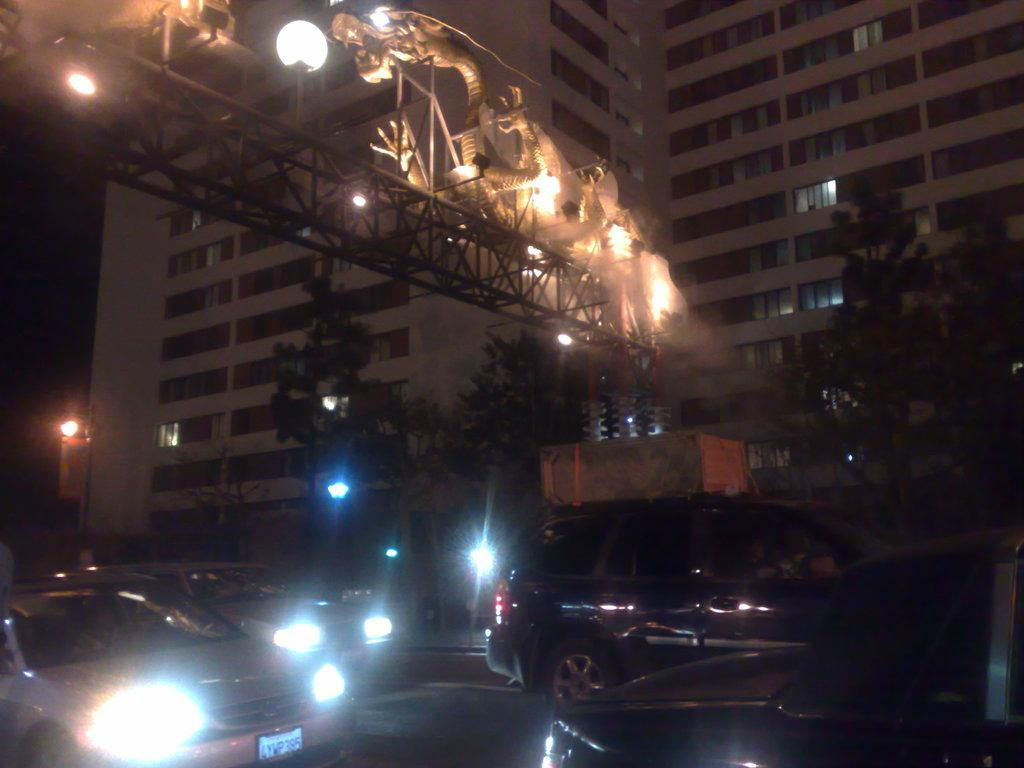What can be seen on the road in the image? There are vehicles on the road in the image. What structure is visible in the image that allows vehicles to cross over a body of water? There is a bridge visible in the image. What type of man-made structures can be seen in the image? There are buildings in the image. What type of natural elements can be seen in the image? Trees are present in the image. Can you tell me how many deer are standing on the bridge in the image? There are no deer present in the image; it features vehicles on the road, a bridge, buildings, and trees. What type of offer is being made by the buildings in the image? There is no offer being made by the buildings in the image; they are simply structures. 